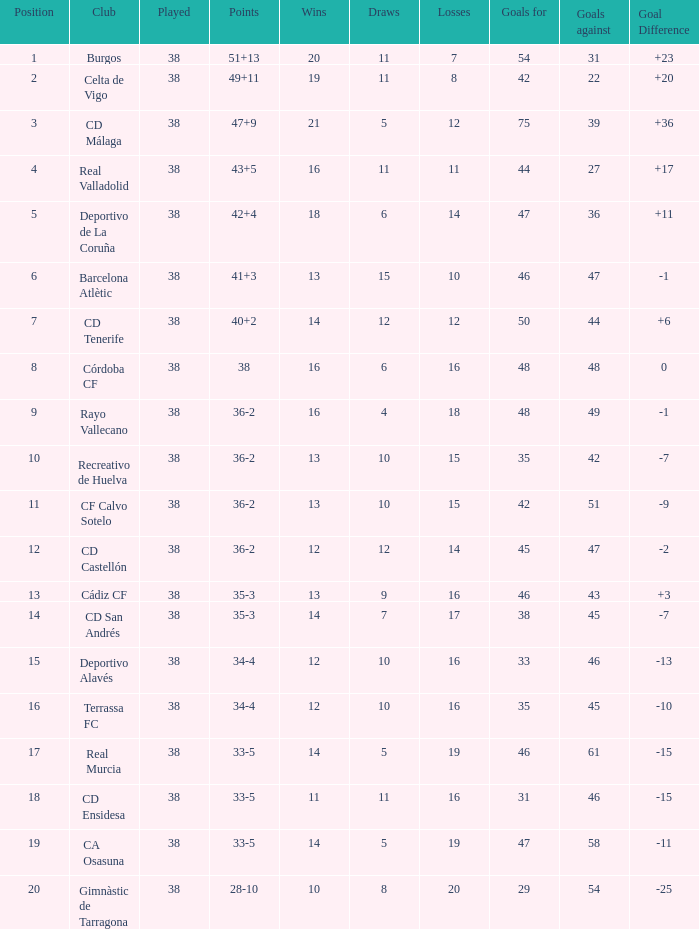Which position is the highest to have less than 54 goals, a loss of 7 and a goal difference higher than 23? None. 